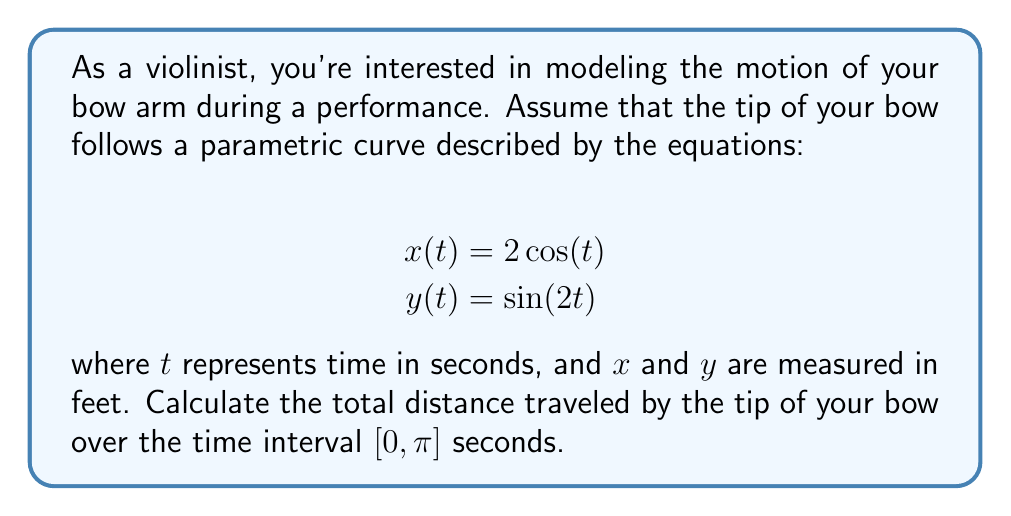Provide a solution to this math problem. To solve this problem, we'll follow these steps:

1) The parametric equations given are:
   $x(t) = 2\cos(t)$
   $y(t) = \sin(2t)$

2) To find the total distance traveled, we need to calculate the arc length of this parametric curve over the interval $[0, \pi]$.

3) The formula for arc length of a parametric curve is:

   $$L = \int_a^b \sqrt{\left(\frac{dx}{dt}\right)^2 + \left(\frac{dy}{dt}\right)^2} dt$$

4) Let's find $\frac{dx}{dt}$ and $\frac{dy}{dt}$:
   
   $\frac{dx}{dt} = -2\sin(t)$
   $\frac{dy}{dt} = 2\cos(2t)$

5) Now, let's substitute these into our arc length formula:

   $$L = \int_0^\pi \sqrt{(-2\sin(t))^2 + (2\cos(2t))^2} dt$$

6) Simplify under the square root:

   $$L = \int_0^\pi \sqrt{4\sin^2(t) + 4\cos^2(2t)} dt$$

7) This integral is quite complex and doesn't have a straightforward antiderivative. We would need to use numerical integration methods to evaluate it precisely.

8) Using a numerical integration method (like Simpson's rule or a computer algebra system), we can approximate the value of this integral.

9) The result of this numerical integration is approximately 5.7525 feet.
Answer: The total distance traveled by the tip of the bow over the time interval $[0, \pi]$ seconds is approximately 5.7525 feet. 